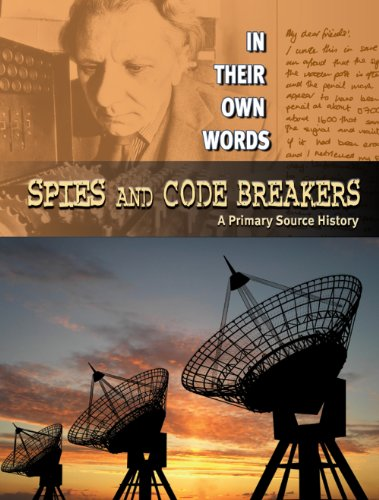What era are the events in this book based on? The events detailed in 'Spies and Code Breakers' are primarily based on World War II, exploring crucial intelligence roles played during the war. 